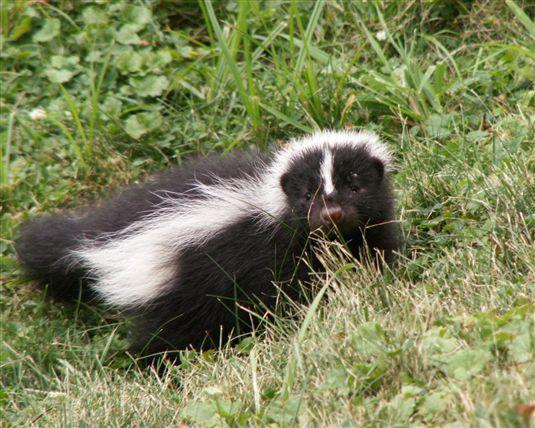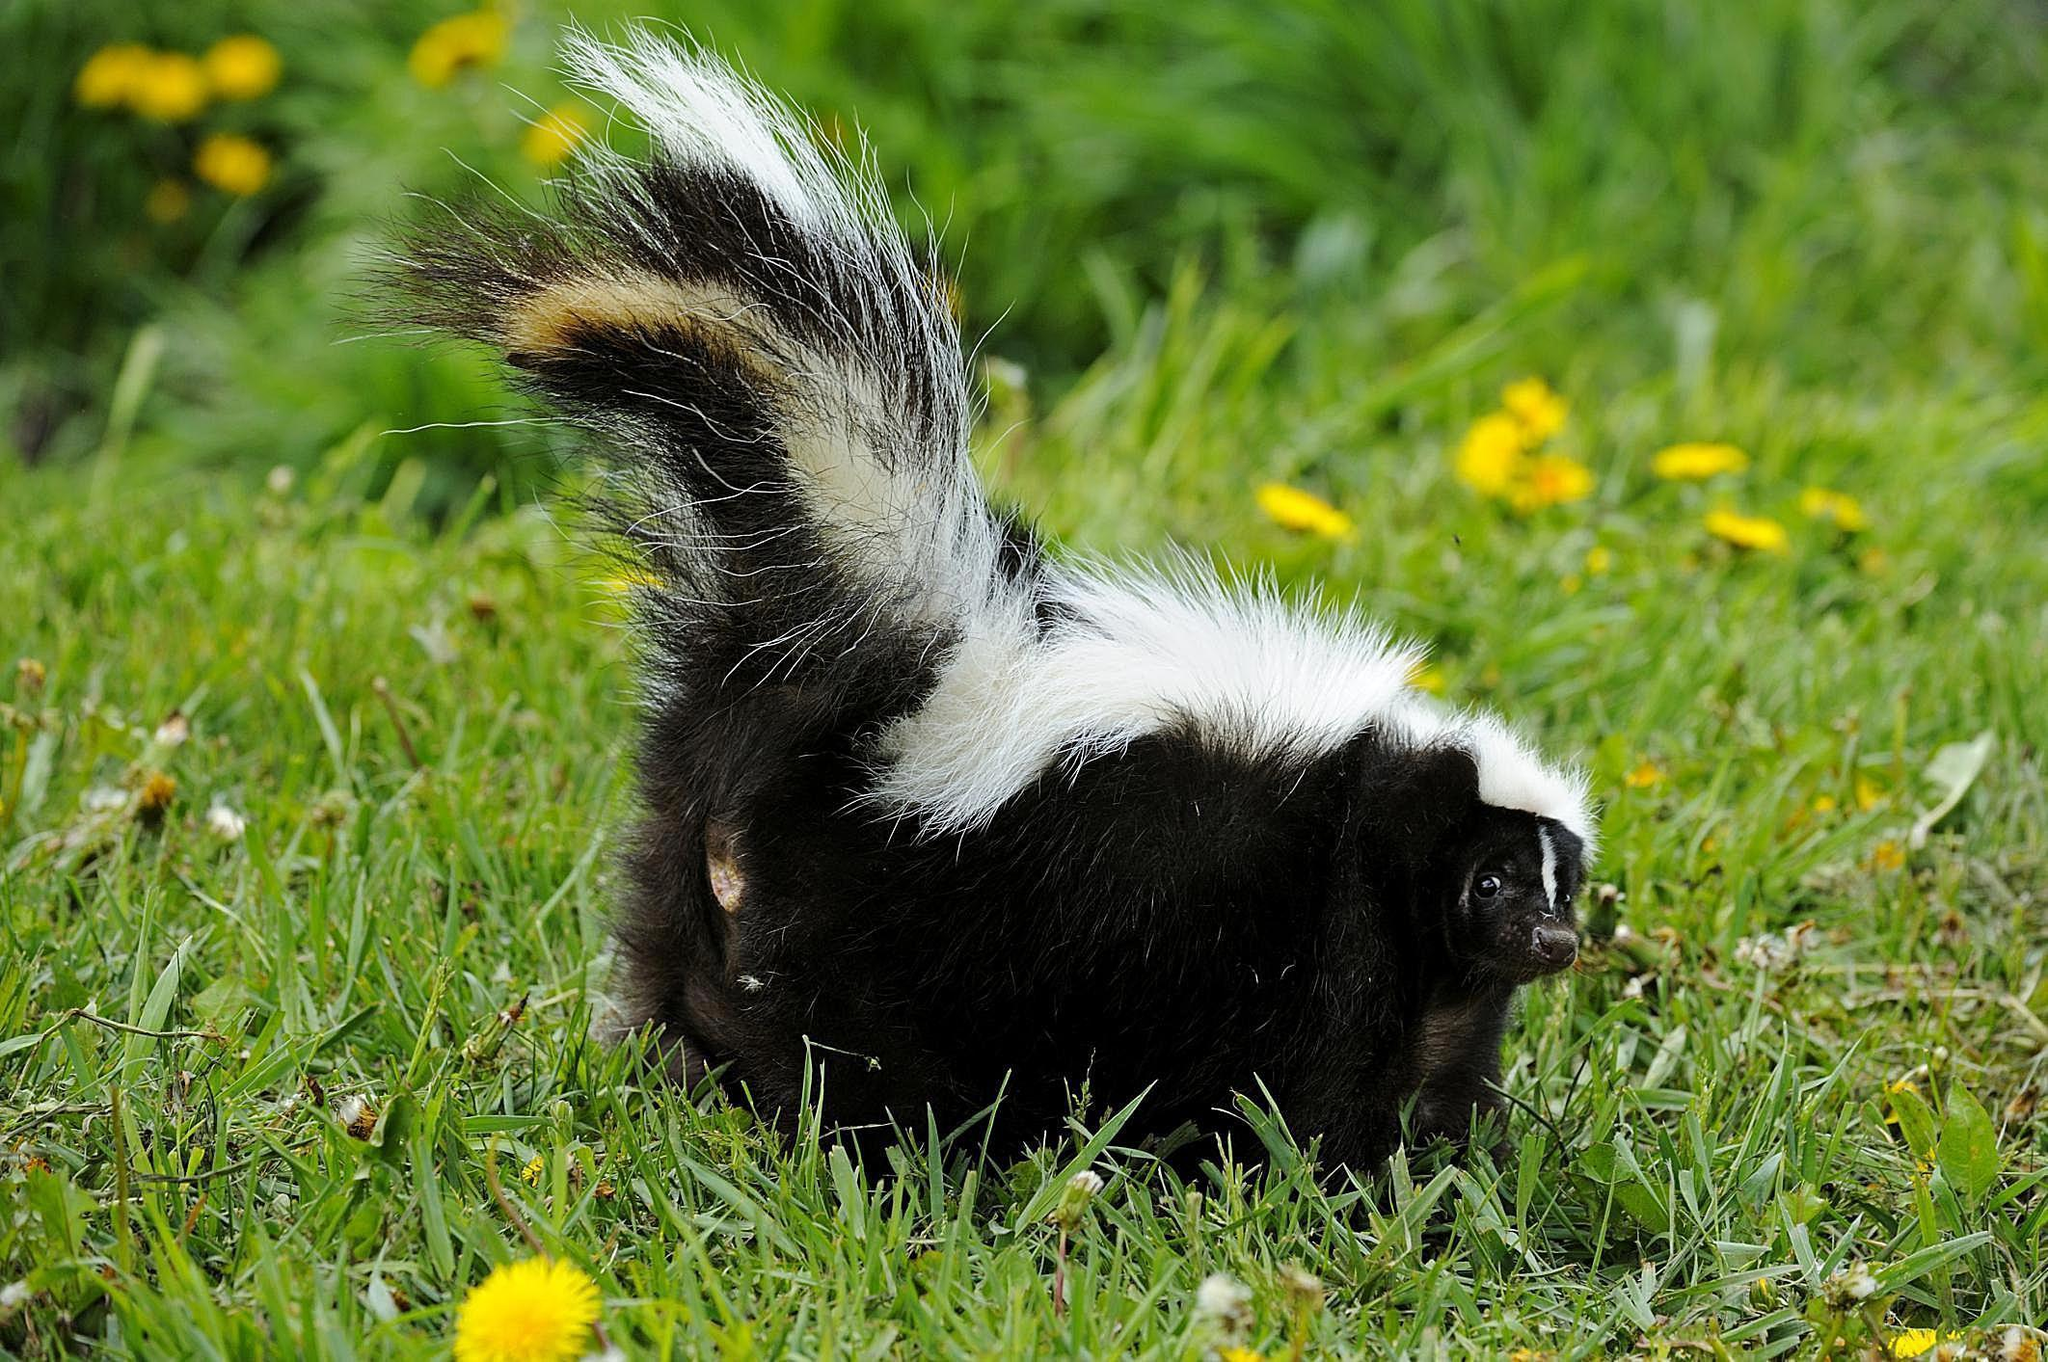The first image is the image on the left, the second image is the image on the right. For the images shown, is this caption "The combined images include at least one erect skunk tail and at least one skunk facing forward." true? Answer yes or no. Yes. The first image is the image on the left, the second image is the image on the right. Examine the images to the left and right. Is the description "there is a skunk peaking out from a fallen tree trunk with just the front part of it's bidy visible" accurate? Answer yes or no. No. 